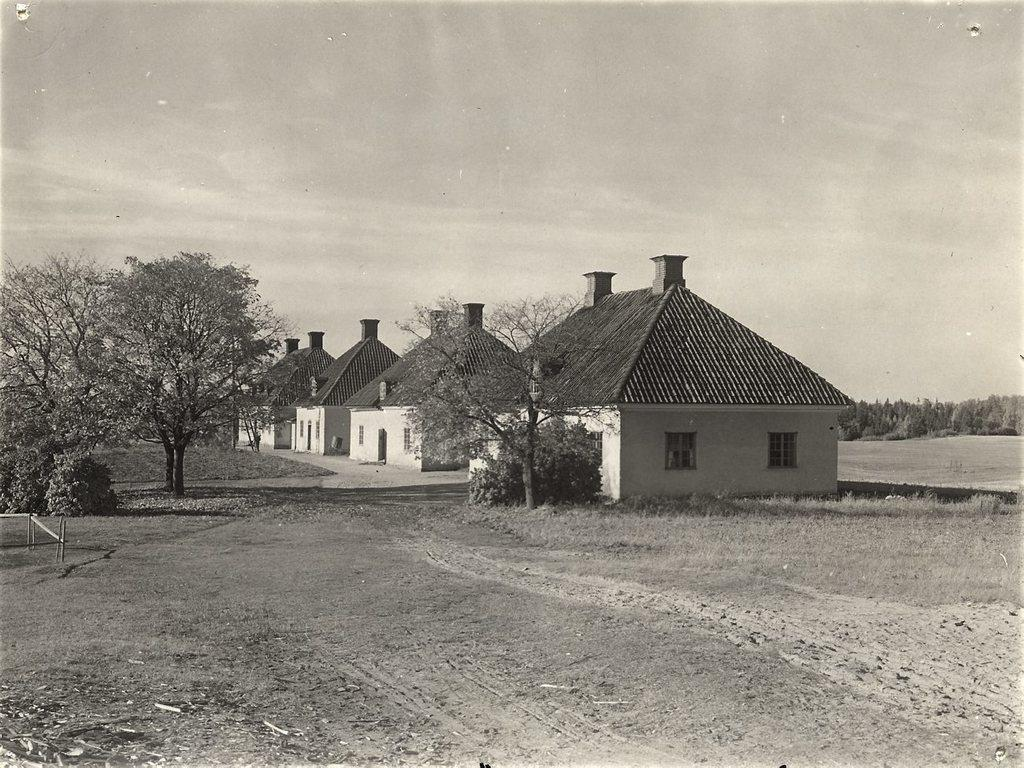What is the color scheme of the image? The image is black and white. What type of natural elements can be seen in the image? There are trees and plants in the image. What type of man-made structures are present in the image? There are houses in the image. What part of the natural environment is visible in the image? The sky is visible in the image. What type of minister is depicted in the image? There is no minister present in the image; it features trees, plants, houses, and a black and white color scheme. What type of crook is visible in the image? There is no crook present in the image; it features trees, plants, houses, and a black and white color scheme. 